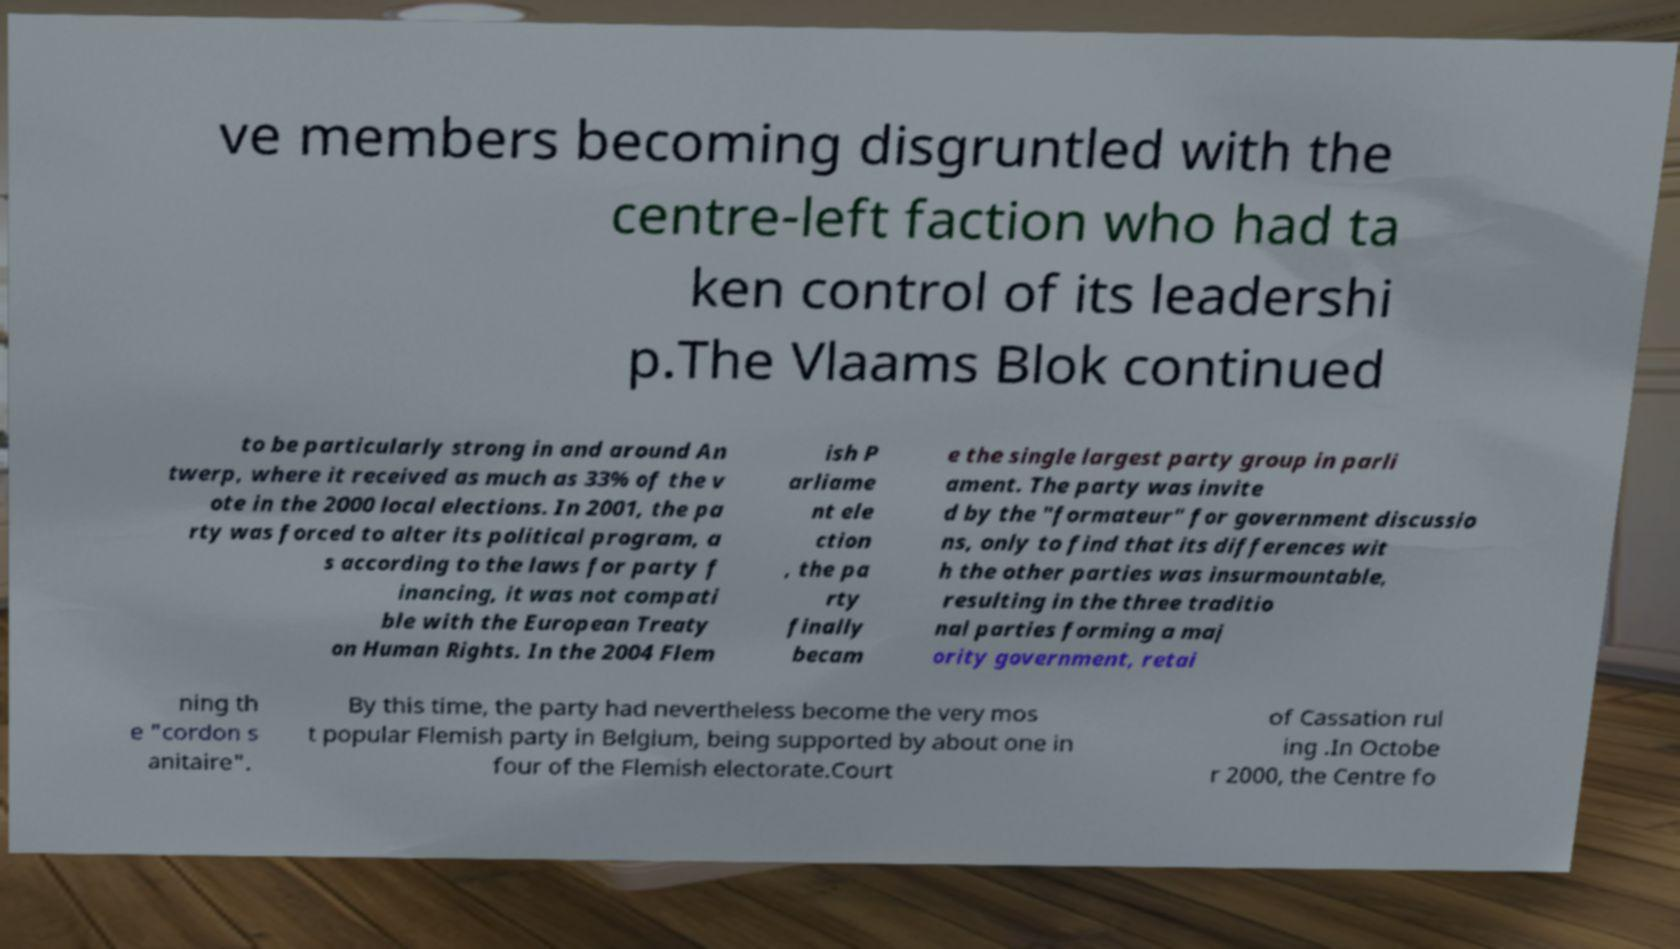Can you accurately transcribe the text from the provided image for me? ve members becoming disgruntled with the centre-left faction who had ta ken control of its leadershi p.The Vlaams Blok continued to be particularly strong in and around An twerp, where it received as much as 33% of the v ote in the 2000 local elections. In 2001, the pa rty was forced to alter its political program, a s according to the laws for party f inancing, it was not compati ble with the European Treaty on Human Rights. In the 2004 Flem ish P arliame nt ele ction , the pa rty finally becam e the single largest party group in parli ament. The party was invite d by the "formateur" for government discussio ns, only to find that its differences wit h the other parties was insurmountable, resulting in the three traditio nal parties forming a maj ority government, retai ning th e "cordon s anitaire". By this time, the party had nevertheless become the very mos t popular Flemish party in Belgium, being supported by about one in four of the Flemish electorate.Court of Cassation rul ing .In Octobe r 2000, the Centre fo 